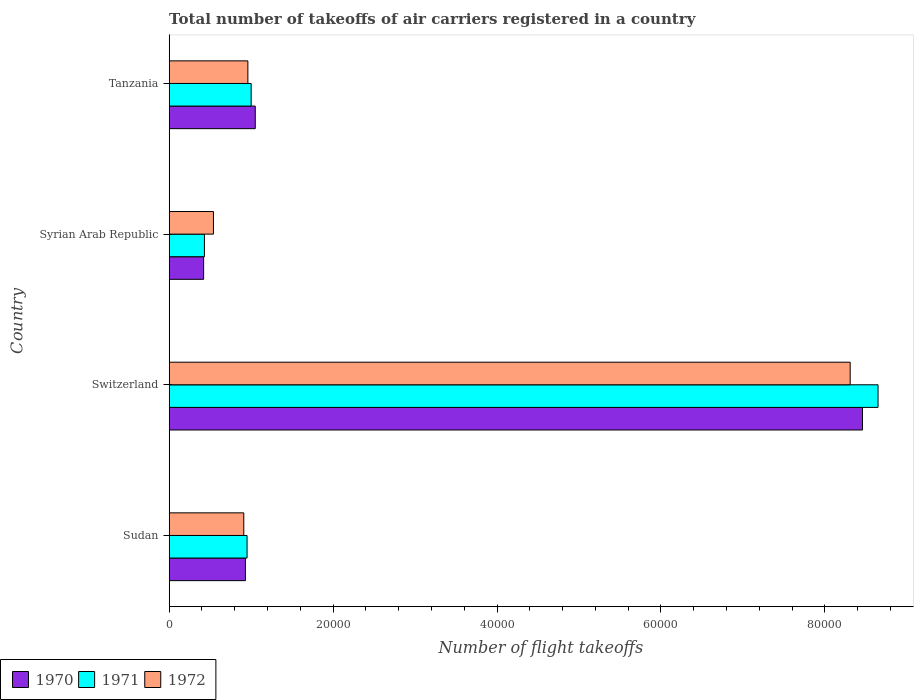How many groups of bars are there?
Offer a very short reply. 4. Are the number of bars per tick equal to the number of legend labels?
Give a very brief answer. Yes. Are the number of bars on each tick of the Y-axis equal?
Keep it short and to the point. Yes. What is the label of the 1st group of bars from the top?
Your answer should be very brief. Tanzania. In how many cases, is the number of bars for a given country not equal to the number of legend labels?
Ensure brevity in your answer.  0. What is the total number of flight takeoffs in 1970 in Tanzania?
Your response must be concise. 1.05e+04. Across all countries, what is the maximum total number of flight takeoffs in 1971?
Offer a terse response. 8.65e+04. Across all countries, what is the minimum total number of flight takeoffs in 1972?
Your answer should be very brief. 5400. In which country was the total number of flight takeoffs in 1970 maximum?
Ensure brevity in your answer.  Switzerland. In which country was the total number of flight takeoffs in 1972 minimum?
Offer a very short reply. Syrian Arab Republic. What is the total total number of flight takeoffs in 1970 in the graph?
Provide a short and direct response. 1.09e+05. What is the difference between the total number of flight takeoffs in 1972 in Sudan and that in Switzerland?
Offer a very short reply. -7.40e+04. What is the difference between the total number of flight takeoffs in 1970 in Sudan and the total number of flight takeoffs in 1971 in Switzerland?
Keep it short and to the point. -7.72e+04. What is the average total number of flight takeoffs in 1970 per country?
Ensure brevity in your answer.  2.72e+04. What is the difference between the total number of flight takeoffs in 1970 and total number of flight takeoffs in 1972 in Switzerland?
Your answer should be very brief. 1500. What is the ratio of the total number of flight takeoffs in 1971 in Sudan to that in Tanzania?
Provide a short and direct response. 0.95. Is the total number of flight takeoffs in 1971 in Sudan less than that in Tanzania?
Provide a short and direct response. Yes. Is the difference between the total number of flight takeoffs in 1970 in Syrian Arab Republic and Tanzania greater than the difference between the total number of flight takeoffs in 1972 in Syrian Arab Republic and Tanzania?
Your answer should be compact. No. What is the difference between the highest and the second highest total number of flight takeoffs in 1972?
Provide a short and direct response. 7.35e+04. What is the difference between the highest and the lowest total number of flight takeoffs in 1971?
Give a very brief answer. 8.22e+04. Is the sum of the total number of flight takeoffs in 1970 in Switzerland and Tanzania greater than the maximum total number of flight takeoffs in 1972 across all countries?
Offer a terse response. Yes. What does the 1st bar from the top in Syrian Arab Republic represents?
Your answer should be compact. 1972. What does the 1st bar from the bottom in Syrian Arab Republic represents?
Offer a very short reply. 1970. Is it the case that in every country, the sum of the total number of flight takeoffs in 1971 and total number of flight takeoffs in 1972 is greater than the total number of flight takeoffs in 1970?
Keep it short and to the point. Yes. Are all the bars in the graph horizontal?
Your answer should be very brief. Yes. How many countries are there in the graph?
Make the answer very short. 4. What is the difference between two consecutive major ticks on the X-axis?
Your response must be concise. 2.00e+04. Does the graph contain any zero values?
Provide a succinct answer. No. How many legend labels are there?
Provide a short and direct response. 3. How are the legend labels stacked?
Your answer should be compact. Horizontal. What is the title of the graph?
Provide a succinct answer. Total number of takeoffs of air carriers registered in a country. Does "2005" appear as one of the legend labels in the graph?
Ensure brevity in your answer.  No. What is the label or title of the X-axis?
Give a very brief answer. Number of flight takeoffs. What is the label or title of the Y-axis?
Provide a short and direct response. Country. What is the Number of flight takeoffs in 1970 in Sudan?
Offer a very short reply. 9300. What is the Number of flight takeoffs in 1971 in Sudan?
Give a very brief answer. 9500. What is the Number of flight takeoffs in 1972 in Sudan?
Give a very brief answer. 9100. What is the Number of flight takeoffs of 1970 in Switzerland?
Make the answer very short. 8.46e+04. What is the Number of flight takeoffs in 1971 in Switzerland?
Offer a terse response. 8.65e+04. What is the Number of flight takeoffs in 1972 in Switzerland?
Provide a short and direct response. 8.31e+04. What is the Number of flight takeoffs of 1970 in Syrian Arab Republic?
Ensure brevity in your answer.  4200. What is the Number of flight takeoffs of 1971 in Syrian Arab Republic?
Ensure brevity in your answer.  4300. What is the Number of flight takeoffs in 1972 in Syrian Arab Republic?
Ensure brevity in your answer.  5400. What is the Number of flight takeoffs of 1970 in Tanzania?
Make the answer very short. 1.05e+04. What is the Number of flight takeoffs of 1971 in Tanzania?
Offer a terse response. 10000. What is the Number of flight takeoffs in 1972 in Tanzania?
Your answer should be compact. 9600. Across all countries, what is the maximum Number of flight takeoffs in 1970?
Make the answer very short. 8.46e+04. Across all countries, what is the maximum Number of flight takeoffs in 1971?
Provide a short and direct response. 8.65e+04. Across all countries, what is the maximum Number of flight takeoffs in 1972?
Keep it short and to the point. 8.31e+04. Across all countries, what is the minimum Number of flight takeoffs of 1970?
Make the answer very short. 4200. Across all countries, what is the minimum Number of flight takeoffs of 1971?
Your answer should be very brief. 4300. Across all countries, what is the minimum Number of flight takeoffs in 1972?
Offer a very short reply. 5400. What is the total Number of flight takeoffs in 1970 in the graph?
Give a very brief answer. 1.09e+05. What is the total Number of flight takeoffs of 1971 in the graph?
Your answer should be very brief. 1.10e+05. What is the total Number of flight takeoffs in 1972 in the graph?
Keep it short and to the point. 1.07e+05. What is the difference between the Number of flight takeoffs in 1970 in Sudan and that in Switzerland?
Give a very brief answer. -7.53e+04. What is the difference between the Number of flight takeoffs in 1971 in Sudan and that in Switzerland?
Provide a succinct answer. -7.70e+04. What is the difference between the Number of flight takeoffs in 1972 in Sudan and that in Switzerland?
Offer a very short reply. -7.40e+04. What is the difference between the Number of flight takeoffs of 1970 in Sudan and that in Syrian Arab Republic?
Provide a short and direct response. 5100. What is the difference between the Number of flight takeoffs of 1971 in Sudan and that in Syrian Arab Republic?
Offer a very short reply. 5200. What is the difference between the Number of flight takeoffs in 1972 in Sudan and that in Syrian Arab Republic?
Your answer should be compact. 3700. What is the difference between the Number of flight takeoffs in 1970 in Sudan and that in Tanzania?
Keep it short and to the point. -1200. What is the difference between the Number of flight takeoffs in 1971 in Sudan and that in Tanzania?
Keep it short and to the point. -500. What is the difference between the Number of flight takeoffs in 1972 in Sudan and that in Tanzania?
Your answer should be very brief. -500. What is the difference between the Number of flight takeoffs of 1970 in Switzerland and that in Syrian Arab Republic?
Make the answer very short. 8.04e+04. What is the difference between the Number of flight takeoffs of 1971 in Switzerland and that in Syrian Arab Republic?
Your response must be concise. 8.22e+04. What is the difference between the Number of flight takeoffs in 1972 in Switzerland and that in Syrian Arab Republic?
Give a very brief answer. 7.77e+04. What is the difference between the Number of flight takeoffs of 1970 in Switzerland and that in Tanzania?
Offer a terse response. 7.41e+04. What is the difference between the Number of flight takeoffs in 1971 in Switzerland and that in Tanzania?
Your answer should be very brief. 7.65e+04. What is the difference between the Number of flight takeoffs of 1972 in Switzerland and that in Tanzania?
Provide a short and direct response. 7.35e+04. What is the difference between the Number of flight takeoffs of 1970 in Syrian Arab Republic and that in Tanzania?
Ensure brevity in your answer.  -6300. What is the difference between the Number of flight takeoffs in 1971 in Syrian Arab Republic and that in Tanzania?
Your answer should be compact. -5700. What is the difference between the Number of flight takeoffs of 1972 in Syrian Arab Republic and that in Tanzania?
Offer a very short reply. -4200. What is the difference between the Number of flight takeoffs of 1970 in Sudan and the Number of flight takeoffs of 1971 in Switzerland?
Make the answer very short. -7.72e+04. What is the difference between the Number of flight takeoffs of 1970 in Sudan and the Number of flight takeoffs of 1972 in Switzerland?
Offer a terse response. -7.38e+04. What is the difference between the Number of flight takeoffs of 1971 in Sudan and the Number of flight takeoffs of 1972 in Switzerland?
Ensure brevity in your answer.  -7.36e+04. What is the difference between the Number of flight takeoffs in 1970 in Sudan and the Number of flight takeoffs in 1972 in Syrian Arab Republic?
Your response must be concise. 3900. What is the difference between the Number of flight takeoffs of 1971 in Sudan and the Number of flight takeoffs of 1972 in Syrian Arab Republic?
Offer a very short reply. 4100. What is the difference between the Number of flight takeoffs of 1970 in Sudan and the Number of flight takeoffs of 1971 in Tanzania?
Provide a short and direct response. -700. What is the difference between the Number of flight takeoffs of 1970 in Sudan and the Number of flight takeoffs of 1972 in Tanzania?
Your answer should be very brief. -300. What is the difference between the Number of flight takeoffs of 1971 in Sudan and the Number of flight takeoffs of 1972 in Tanzania?
Offer a terse response. -100. What is the difference between the Number of flight takeoffs in 1970 in Switzerland and the Number of flight takeoffs in 1971 in Syrian Arab Republic?
Provide a short and direct response. 8.03e+04. What is the difference between the Number of flight takeoffs in 1970 in Switzerland and the Number of flight takeoffs in 1972 in Syrian Arab Republic?
Keep it short and to the point. 7.92e+04. What is the difference between the Number of flight takeoffs in 1971 in Switzerland and the Number of flight takeoffs in 1972 in Syrian Arab Republic?
Give a very brief answer. 8.11e+04. What is the difference between the Number of flight takeoffs of 1970 in Switzerland and the Number of flight takeoffs of 1971 in Tanzania?
Provide a short and direct response. 7.46e+04. What is the difference between the Number of flight takeoffs of 1970 in Switzerland and the Number of flight takeoffs of 1972 in Tanzania?
Keep it short and to the point. 7.50e+04. What is the difference between the Number of flight takeoffs of 1971 in Switzerland and the Number of flight takeoffs of 1972 in Tanzania?
Make the answer very short. 7.69e+04. What is the difference between the Number of flight takeoffs of 1970 in Syrian Arab Republic and the Number of flight takeoffs of 1971 in Tanzania?
Your response must be concise. -5800. What is the difference between the Number of flight takeoffs of 1970 in Syrian Arab Republic and the Number of flight takeoffs of 1972 in Tanzania?
Give a very brief answer. -5400. What is the difference between the Number of flight takeoffs in 1971 in Syrian Arab Republic and the Number of flight takeoffs in 1972 in Tanzania?
Offer a very short reply. -5300. What is the average Number of flight takeoffs of 1970 per country?
Make the answer very short. 2.72e+04. What is the average Number of flight takeoffs of 1971 per country?
Give a very brief answer. 2.76e+04. What is the average Number of flight takeoffs of 1972 per country?
Keep it short and to the point. 2.68e+04. What is the difference between the Number of flight takeoffs in 1970 and Number of flight takeoffs in 1971 in Sudan?
Give a very brief answer. -200. What is the difference between the Number of flight takeoffs in 1970 and Number of flight takeoffs in 1972 in Sudan?
Make the answer very short. 200. What is the difference between the Number of flight takeoffs of 1970 and Number of flight takeoffs of 1971 in Switzerland?
Your answer should be very brief. -1900. What is the difference between the Number of flight takeoffs in 1970 and Number of flight takeoffs in 1972 in Switzerland?
Keep it short and to the point. 1500. What is the difference between the Number of flight takeoffs in 1971 and Number of flight takeoffs in 1972 in Switzerland?
Offer a terse response. 3400. What is the difference between the Number of flight takeoffs in 1970 and Number of flight takeoffs in 1971 in Syrian Arab Republic?
Offer a terse response. -100. What is the difference between the Number of flight takeoffs of 1970 and Number of flight takeoffs of 1972 in Syrian Arab Republic?
Your answer should be very brief. -1200. What is the difference between the Number of flight takeoffs in 1971 and Number of flight takeoffs in 1972 in Syrian Arab Republic?
Your answer should be very brief. -1100. What is the difference between the Number of flight takeoffs of 1970 and Number of flight takeoffs of 1971 in Tanzania?
Give a very brief answer. 500. What is the difference between the Number of flight takeoffs of 1970 and Number of flight takeoffs of 1972 in Tanzania?
Your answer should be compact. 900. What is the difference between the Number of flight takeoffs of 1971 and Number of flight takeoffs of 1972 in Tanzania?
Your response must be concise. 400. What is the ratio of the Number of flight takeoffs in 1970 in Sudan to that in Switzerland?
Ensure brevity in your answer.  0.11. What is the ratio of the Number of flight takeoffs in 1971 in Sudan to that in Switzerland?
Give a very brief answer. 0.11. What is the ratio of the Number of flight takeoffs in 1972 in Sudan to that in Switzerland?
Keep it short and to the point. 0.11. What is the ratio of the Number of flight takeoffs in 1970 in Sudan to that in Syrian Arab Republic?
Keep it short and to the point. 2.21. What is the ratio of the Number of flight takeoffs in 1971 in Sudan to that in Syrian Arab Republic?
Offer a very short reply. 2.21. What is the ratio of the Number of flight takeoffs of 1972 in Sudan to that in Syrian Arab Republic?
Your answer should be very brief. 1.69. What is the ratio of the Number of flight takeoffs in 1970 in Sudan to that in Tanzania?
Your answer should be very brief. 0.89. What is the ratio of the Number of flight takeoffs of 1971 in Sudan to that in Tanzania?
Provide a short and direct response. 0.95. What is the ratio of the Number of flight takeoffs of 1972 in Sudan to that in Tanzania?
Give a very brief answer. 0.95. What is the ratio of the Number of flight takeoffs in 1970 in Switzerland to that in Syrian Arab Republic?
Provide a succinct answer. 20.14. What is the ratio of the Number of flight takeoffs in 1971 in Switzerland to that in Syrian Arab Republic?
Give a very brief answer. 20.12. What is the ratio of the Number of flight takeoffs in 1972 in Switzerland to that in Syrian Arab Republic?
Offer a terse response. 15.39. What is the ratio of the Number of flight takeoffs in 1970 in Switzerland to that in Tanzania?
Provide a short and direct response. 8.06. What is the ratio of the Number of flight takeoffs in 1971 in Switzerland to that in Tanzania?
Provide a short and direct response. 8.65. What is the ratio of the Number of flight takeoffs of 1972 in Switzerland to that in Tanzania?
Offer a very short reply. 8.66. What is the ratio of the Number of flight takeoffs in 1971 in Syrian Arab Republic to that in Tanzania?
Give a very brief answer. 0.43. What is the ratio of the Number of flight takeoffs in 1972 in Syrian Arab Republic to that in Tanzania?
Make the answer very short. 0.56. What is the difference between the highest and the second highest Number of flight takeoffs of 1970?
Your answer should be compact. 7.41e+04. What is the difference between the highest and the second highest Number of flight takeoffs of 1971?
Ensure brevity in your answer.  7.65e+04. What is the difference between the highest and the second highest Number of flight takeoffs of 1972?
Your answer should be very brief. 7.35e+04. What is the difference between the highest and the lowest Number of flight takeoffs of 1970?
Ensure brevity in your answer.  8.04e+04. What is the difference between the highest and the lowest Number of flight takeoffs in 1971?
Your response must be concise. 8.22e+04. What is the difference between the highest and the lowest Number of flight takeoffs of 1972?
Ensure brevity in your answer.  7.77e+04. 